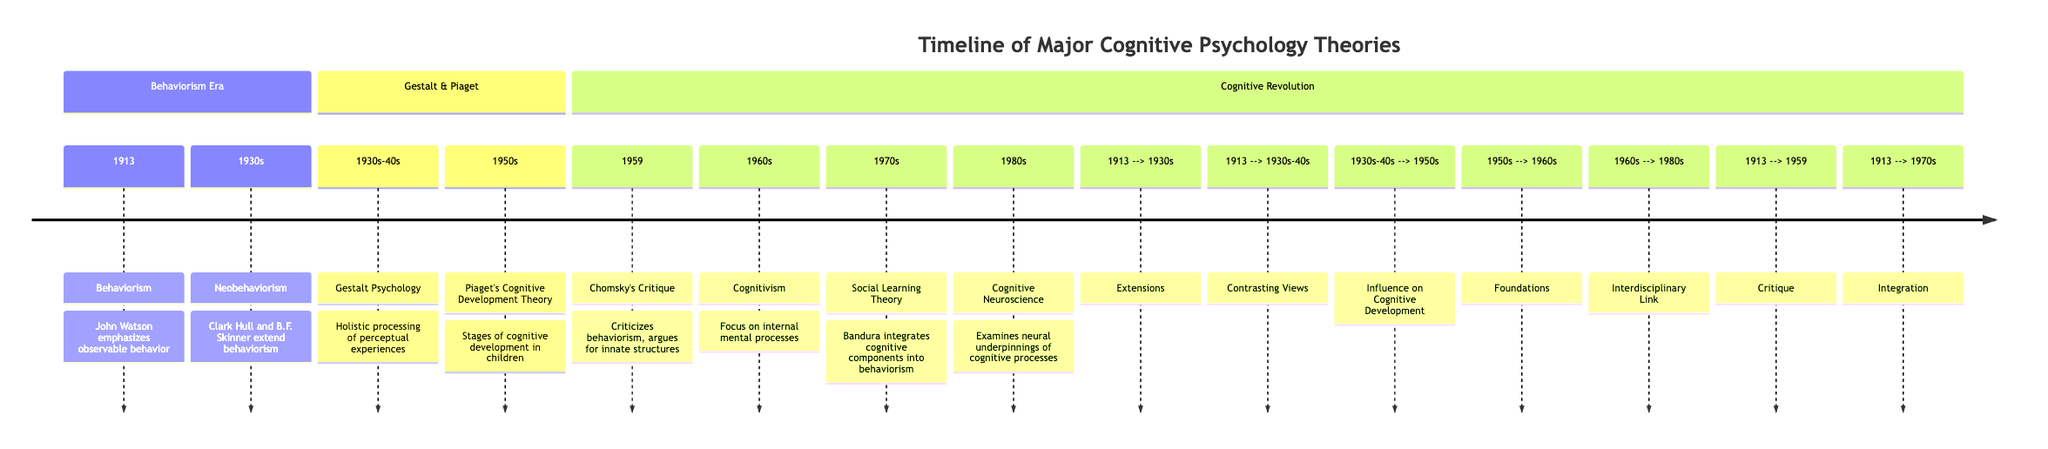What year did Behaviorism emerge? According to the diagram, Behaviorism is marked as starting in 1913. It is the earliest date listed in the timeline.
Answer: 1913 Who critiqued behaviorism in 1959? The diagram indicates that Chomsky's Critique occurred in 1959, thus he is the critic referred to in that year.
Answer: Chomsky How many sections are there in the timeline? The diagram contains three distinct sections: Behaviorism Era, Gestalt & Piaget, and Cognitive Revolution.
Answer: 3 Which theory emphasizes the holistic processing of perceptual experiences? The diagram states that Gestalt Psychology, which covers the 1930s-40s, emphasizes holistic processing.
Answer: Gestalt Psychology What theory links the 1950s to the 1960s? The diagram shows that Piaget's Cognitive Development Theory from the 1950s serves as a foundation for Cognitivism in the 1960s, establishing a link between the two.
Answer: Foundations Which theory integrates cognitive components into behaviorism? The timeline marks Social Learning Theory in the 1970s as the development that integrates cognitive components with behaviorism.
Answer: Social Learning Theory What years represent the period of Gestalt Psychology? The diagram specifies the years spanning from 1930s to 1940s for Gestalt Psychology, thus denoting its time frame.
Answer: 1930s-40s What relationship is depicted between Behaviorism and Neobehaviorism? The connection illustrated in the diagram states that Behaviorism (1913) extends into Neobehaviorism (1930s), indicating a direct influence.
Answer: Extensions In which decade did Cognitive Neuroscience emerge? The diagram positions Cognitive Neuroscience clearly in the 1980s, outlining its emergence during that decade.
Answer: 1980s 